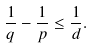Convert formula to latex. <formula><loc_0><loc_0><loc_500><loc_500>\frac { 1 } { q } - \frac { 1 } { p } \leq \frac { 1 } { d } .</formula> 